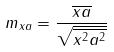<formula> <loc_0><loc_0><loc_500><loc_500>m _ { x a } = \frac { \overline { x a } } { \sqrt { \overline { x ^ { 2 } } \overline { a ^ { 2 } } } }</formula> 